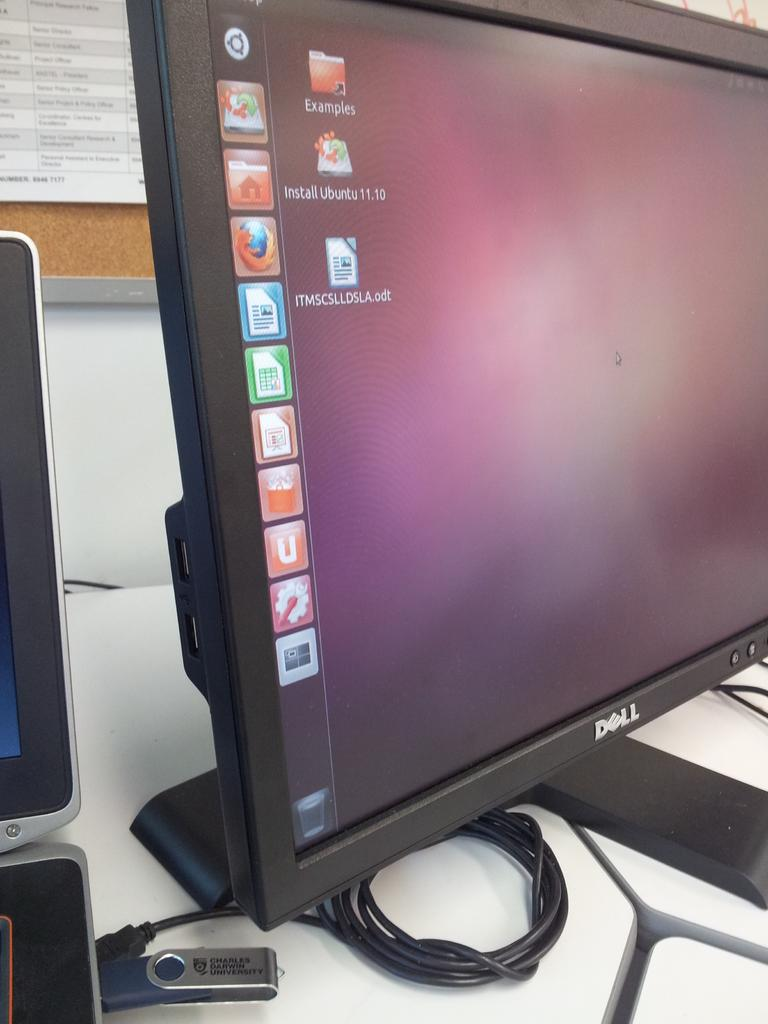Provide a one-sentence caption for the provided image. A DELL brand computer monitor is shown from a side view with icons,  and EXAMPLES folder and a document ITMSCSLLDSLA.odt on the screen. 